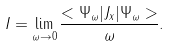<formula> <loc_0><loc_0><loc_500><loc_500>I = \lim _ { \omega \to 0 } \frac { < \Psi _ { \omega } | J _ { x } | \Psi _ { \omega } > } { \omega } .</formula> 